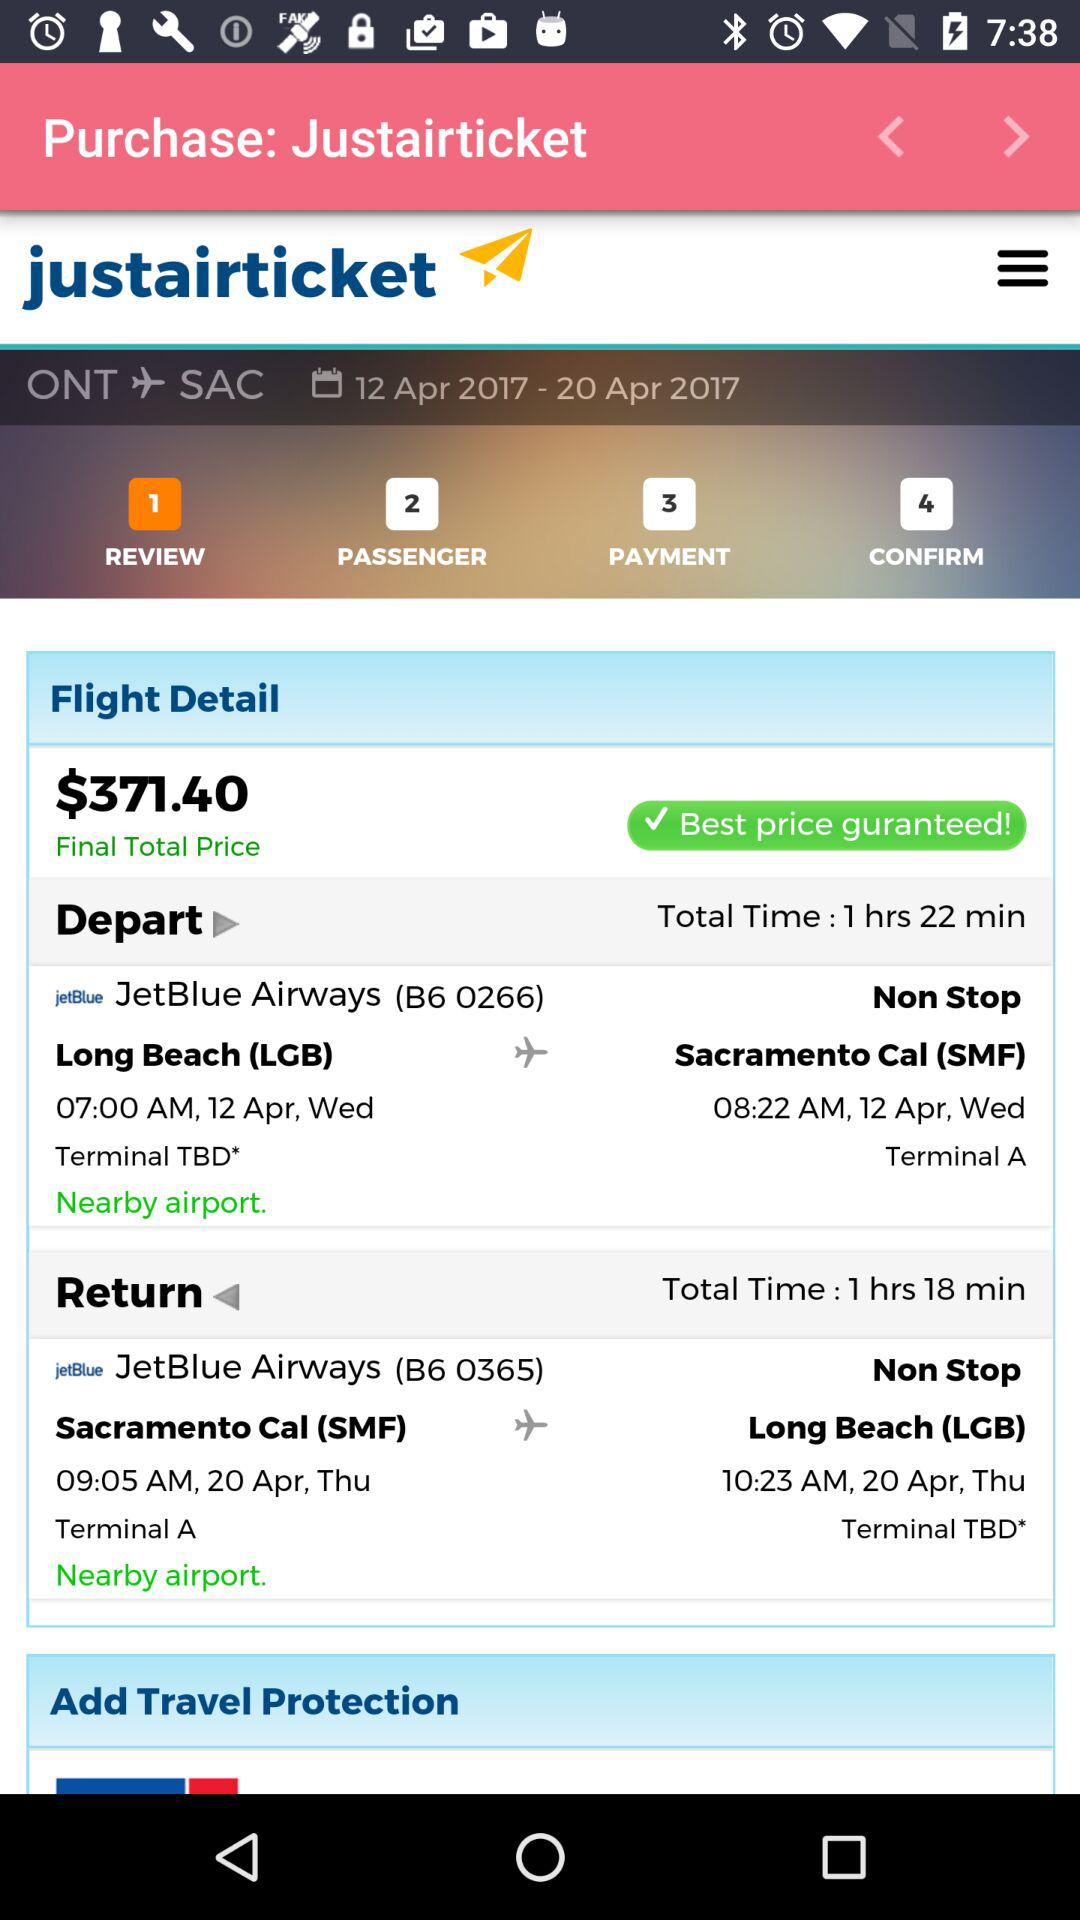What is the total price of the flight? The total price of the flight is $371.40. 